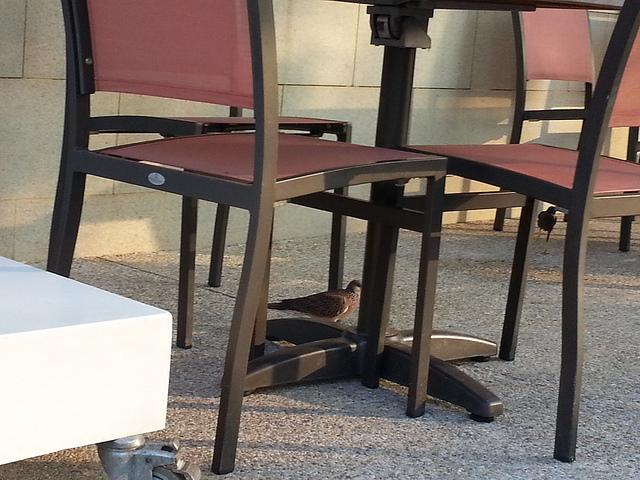Do you see any living animals in this photo?
Concise answer only. Yes. What color are the chair cushions?
Concise answer only. Red. What color are the chairs?
Short answer required. Brown. Are the chairs wooden?
Short answer required. Yes. 